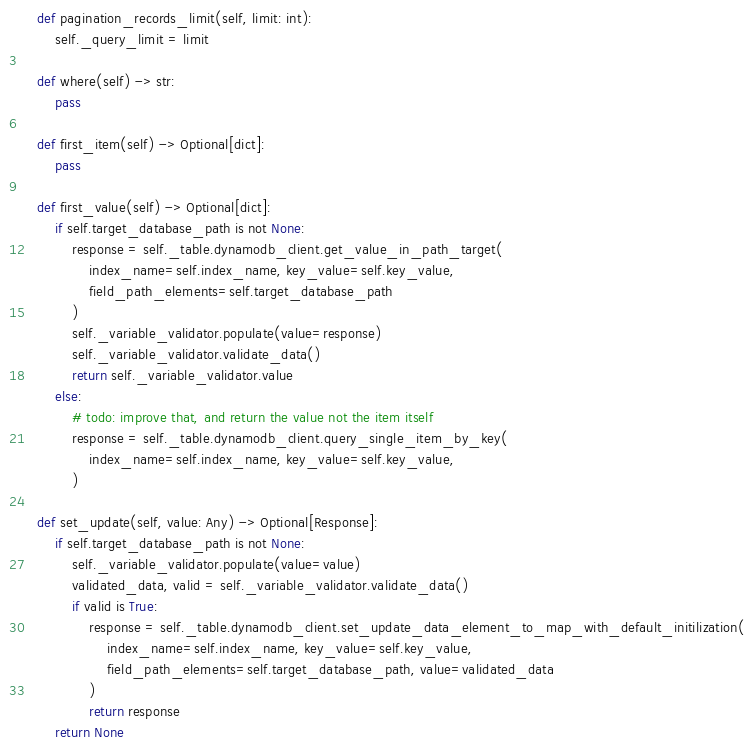<code> <loc_0><loc_0><loc_500><loc_500><_Python_>
    def pagination_records_limit(self, limit: int):
        self._query_limit = limit

    def where(self) -> str:
        pass

    def first_item(self) -> Optional[dict]:
        pass

    def first_value(self) -> Optional[dict]:
        if self.target_database_path is not None:
            response = self._table.dynamodb_client.get_value_in_path_target(
                index_name=self.index_name, key_value=self.key_value,
                field_path_elements=self.target_database_path
            )
            self._variable_validator.populate(value=response)
            self._variable_validator.validate_data()
            return self._variable_validator.value
        else:
            # todo: improve that, and return the value not the item itself
            response = self._table.dynamodb_client.query_single_item_by_key(
                index_name=self.index_name, key_value=self.key_value,
            )

    def set_update(self, value: Any) -> Optional[Response]:
        if self.target_database_path is not None:
            self._variable_validator.populate(value=value)
            validated_data, valid = self._variable_validator.validate_data()
            if valid is True:
                response = self._table.dynamodb_client.set_update_data_element_to_map_with_default_initilization(
                    index_name=self.index_name, key_value=self.key_value,
                    field_path_elements=self.target_database_path, value=validated_data
                )
                return response
        return None
</code> 